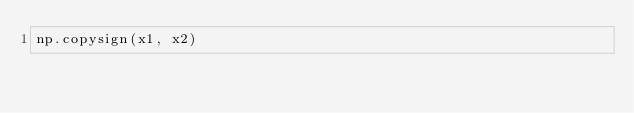Convert code to text. <code><loc_0><loc_0><loc_500><loc_500><_Python_>np.copysign(x1, x2)</code> 